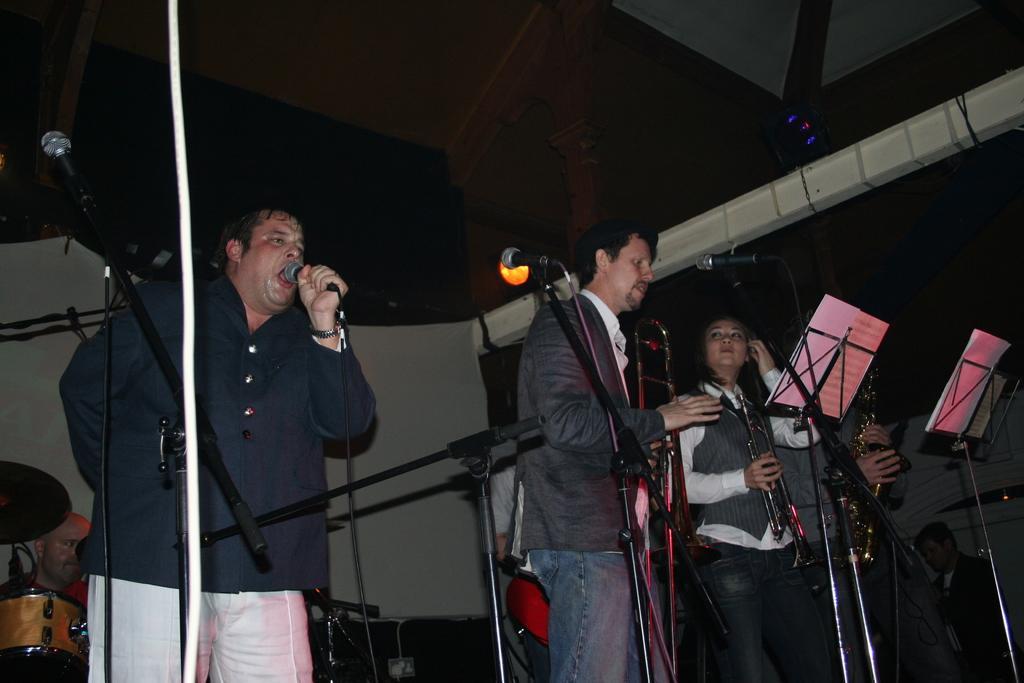Can you describe this image briefly? There are four persons standing on a stage. They are playing a musical instruments. On the left side we have a person. He is singing a song. We can see in background light and curtain. 